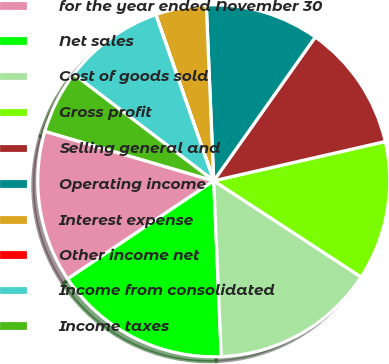Convert chart. <chart><loc_0><loc_0><loc_500><loc_500><pie_chart><fcel>for the year ended November 30<fcel>Net sales<fcel>Cost of goods sold<fcel>Gross profit<fcel>Selling general and<fcel>Operating income<fcel>Interest expense<fcel>Other income net<fcel>Income from consolidated<fcel>Income taxes<nl><fcel>13.95%<fcel>16.27%<fcel>15.11%<fcel>12.79%<fcel>11.63%<fcel>10.46%<fcel>4.66%<fcel>0.01%<fcel>9.3%<fcel>5.82%<nl></chart> 